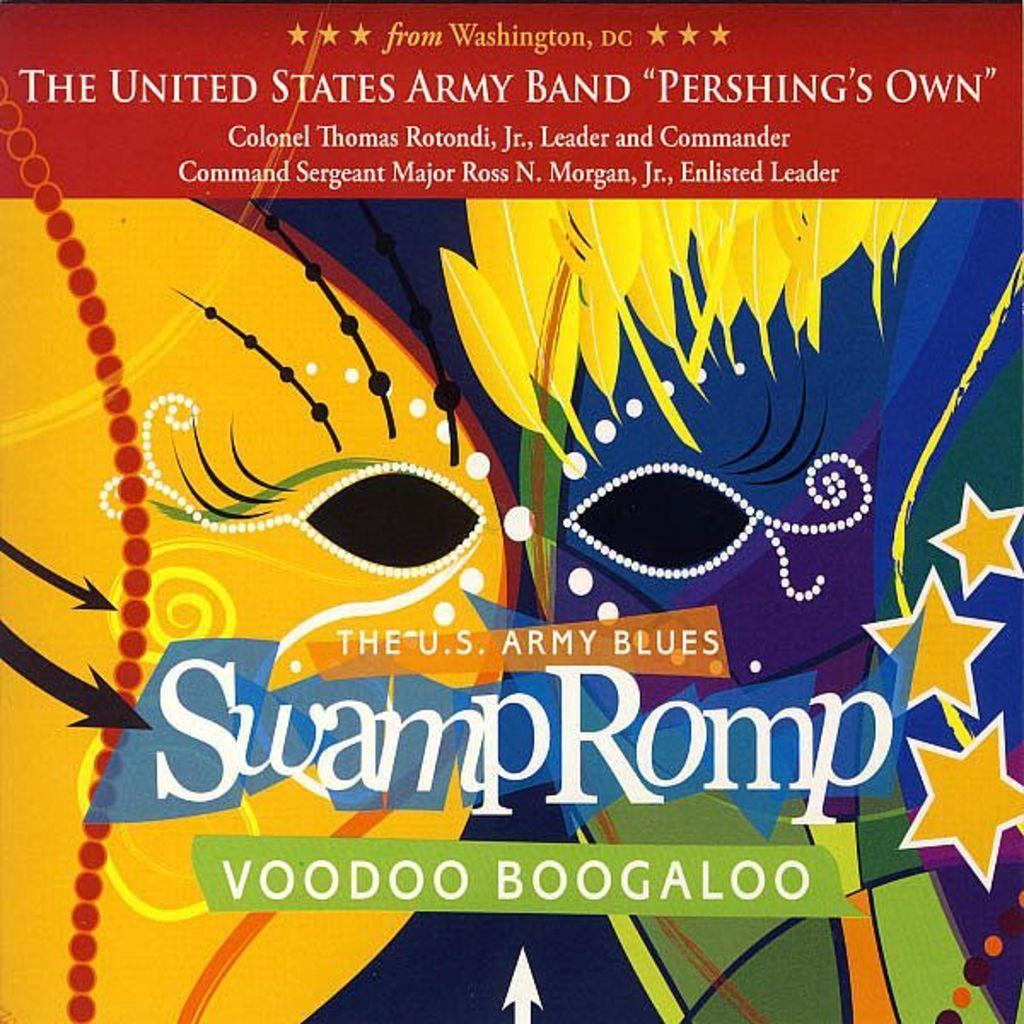Provide a one-sentence caption for the provided image. A book of music called Swamp Romp Voodoo Boogaloo. 